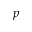Convert formula to latex. <formula><loc_0><loc_0><loc_500><loc_500>p</formula> 